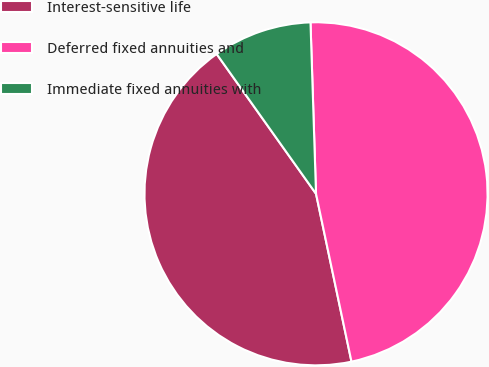<chart> <loc_0><loc_0><loc_500><loc_500><pie_chart><fcel>Interest-sensitive life<fcel>Deferred fixed annuities and<fcel>Immediate fixed annuities with<nl><fcel>43.48%<fcel>47.2%<fcel>9.32%<nl></chart> 